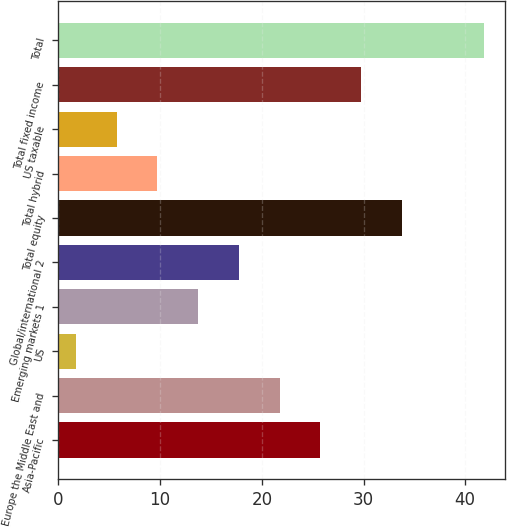<chart> <loc_0><loc_0><loc_500><loc_500><bar_chart><fcel>Asia-Pacific<fcel>Europe the Middle East and<fcel>US<fcel>Emerging markets 1<fcel>Global/international 2<fcel>Total equity<fcel>Total hybrid<fcel>US taxable<fcel>Total fixed income<fcel>Total<nl><fcel>25.76<fcel>21.75<fcel>1.7<fcel>13.73<fcel>17.74<fcel>33.78<fcel>9.72<fcel>5.71<fcel>29.77<fcel>41.8<nl></chart> 